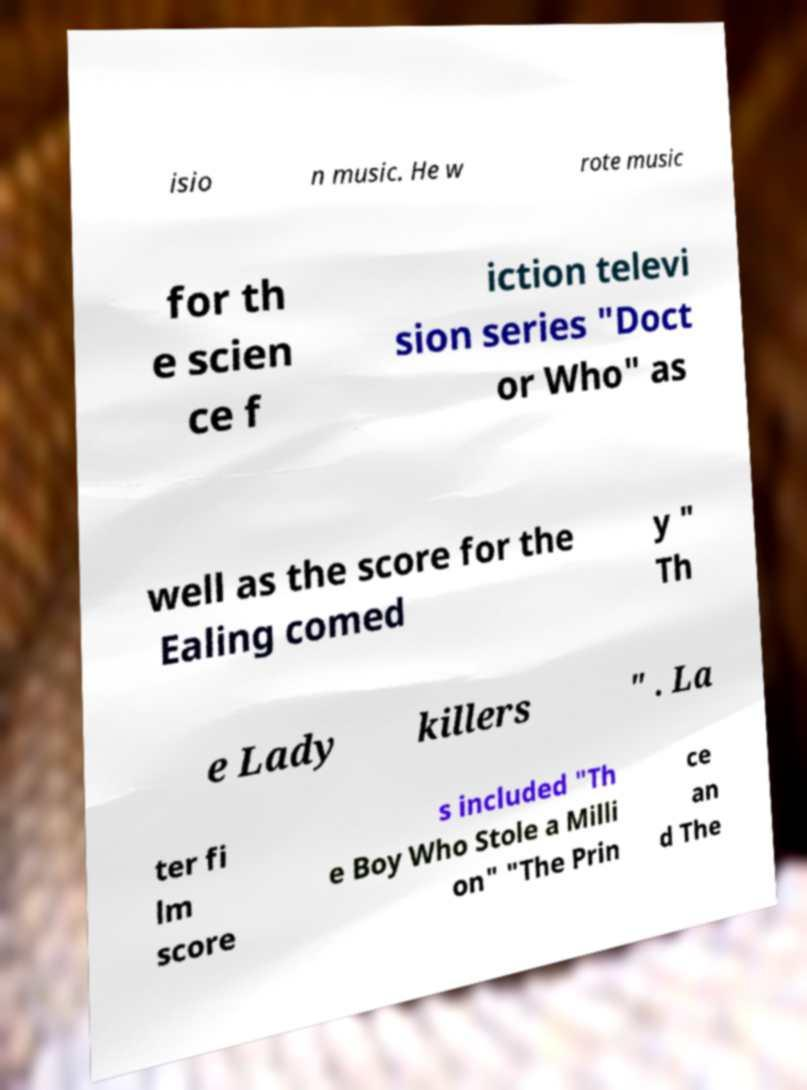Could you extract and type out the text from this image? isio n music. He w rote music for th e scien ce f iction televi sion series "Doct or Who" as well as the score for the Ealing comed y " Th e Lady killers " . La ter fi lm score s included "Th e Boy Who Stole a Milli on" "The Prin ce an d The 